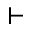Convert formula to latex. <formula><loc_0><loc_0><loc_500><loc_500>\vdash</formula> 